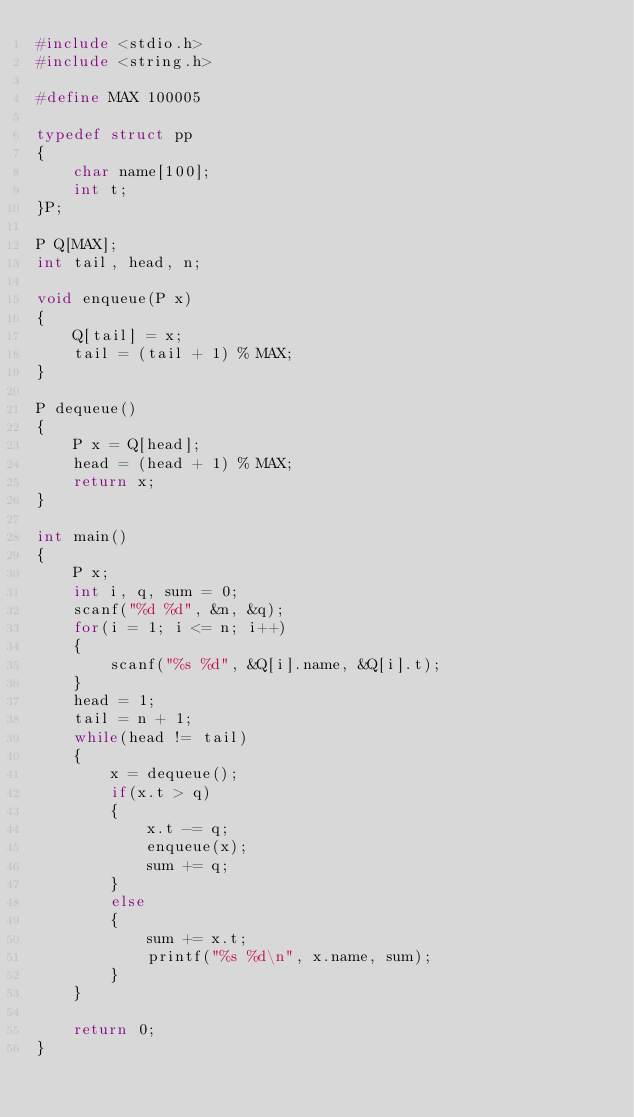Convert code to text. <code><loc_0><loc_0><loc_500><loc_500><_C_>#include <stdio.h>
#include <string.h>
 
#define MAX 100005 

typedef struct pp
{
	char name[100];
	int t;
}P;

P Q[MAX];
int tail, head, n;

void enqueue(P x)
{
	Q[tail] = x;
	tail = (tail + 1) % MAX;
}

P dequeue()
{
	P x = Q[head];
	head = (head + 1) % MAX;
	return x;
}

int main()
{
	P x;
	int i, q, sum = 0;
	scanf("%d %d", &n, &q);
	for(i = 1; i <= n; i++)
	{
		scanf("%s %d", &Q[i].name, &Q[i].t);
	}
	head = 1;
	tail = n + 1;
	while(head != tail)
	{
		x = dequeue();
		if(x.t > q)
		{
			x.t -= q;
			enqueue(x);
			sum += q;
		}
		else
		{
			sum += x.t;
			printf("%s %d\n", x.name, sum);
		}
	}
	
	return 0;
}
</code> 